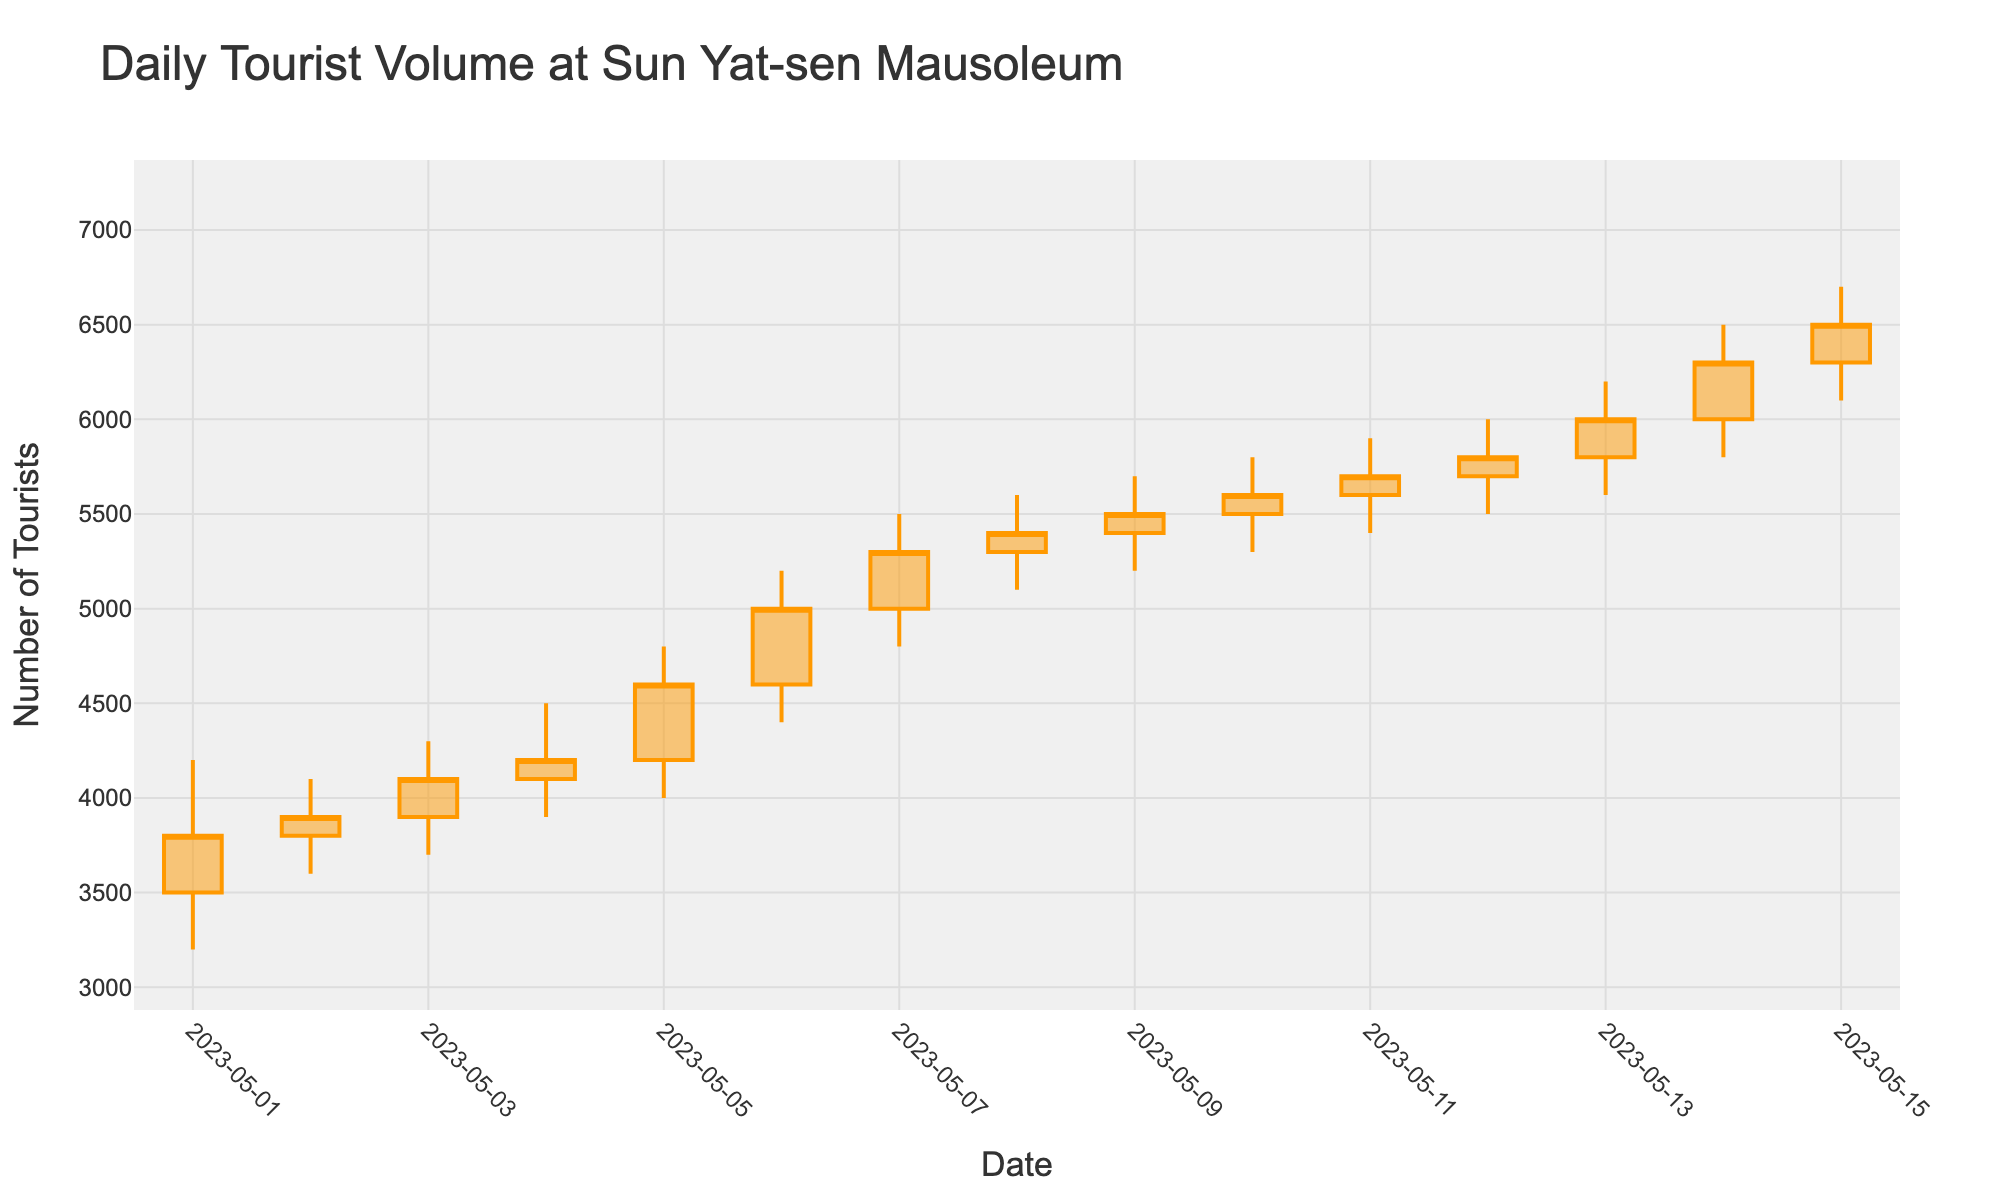What is the title of the chart? The title of the chart is displayed at the top in a larger and bolder font compared to other text. It helps to understand what data is being represented.
Answer: Daily Tourist Volume at Sun Yat-sen Mausoleum On which date was the highest tourist volume recorded? By examining the highest 'high' value in the chart and looking at the corresponding date along the x-axis, we can determine when the highest tourist volume occurred.
Answer: 2023-05-15 Which dates show a decreasing tourist volume from the opening to the closing of the day? In an OHLC chart, a day shows a decreasing volume if the 'Close' value is lower than the 'Open' value. By looking at each data point, we can identify these dates.
Answer: 2023-05-01 and 2023-05-04 What is the range of tourist volumes (from the lowest low to the highest high) depicted in the chart? The range can be determined by identifying the lowest point (min 'Low' value) and the highest point (max 'High' value) in the chart. Subtract the lowest low from the highest high.
Answer: 3300 (6700 - 3400) Compare the tourist volumes on 2023-05-02 and 2023-05-03. Which day had a higher closing volume? Compare the 'Close' values of both dates. On 2023-05-02, the close was 3900; on 2023-05-03, it was 4100.
Answer: 2023-05-03 What was the opening tourist volume on 2023-05-07? By locating the data point for 2023-05-07 and looking at the 'Open' value, we can find the opening tourist volume for that day.
Answer: 5000 How many days did the tourist volume close above 5000? Count the number of days where the 'Close' value is above 5000 by examining each relevant value in the chart.
Answer: 8 days What is the median closing tourist volume over the entire period? To find the median, list all 'Close' values in ascending or descending order and select the middle value. If there's an even number of data points, the median is the average of the two middle numbers.
Answer: 5400 Which date had the smallest difference between the high and low volumes? For each date, calculate the difference between 'High' and 'Low' volumes and identify the date with the smallest difference.
Answer: 2023-05-08 (5600 - 5100 = 500) What is the average closing tourist volume over the first week (May 1 to May 7)? Sum the 'Close' values for the dates from May 1 to May 7 and divide by the number of days (7) to find the average.
Answer: 4271.43 